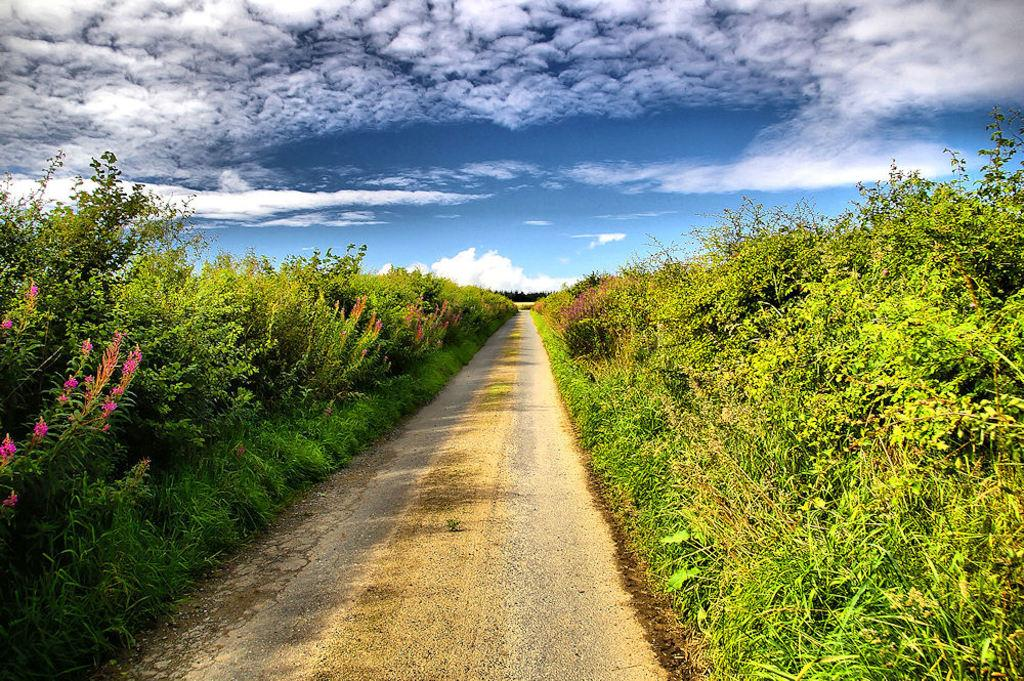What can be seen in the image that people might walk on? There is a pathway in the image that people might walk on. What type of vegetation is present alongside the pathway? Trees are present on both sides of the pathway. What is visible in the background of the image? The sky is visible behind the trees and appears to be cloudy. How many sheep are grazing on the pathway in the image? There are no sheep present in the image; it features a pathway with trees on both sides and a cloudy sky in the background. 